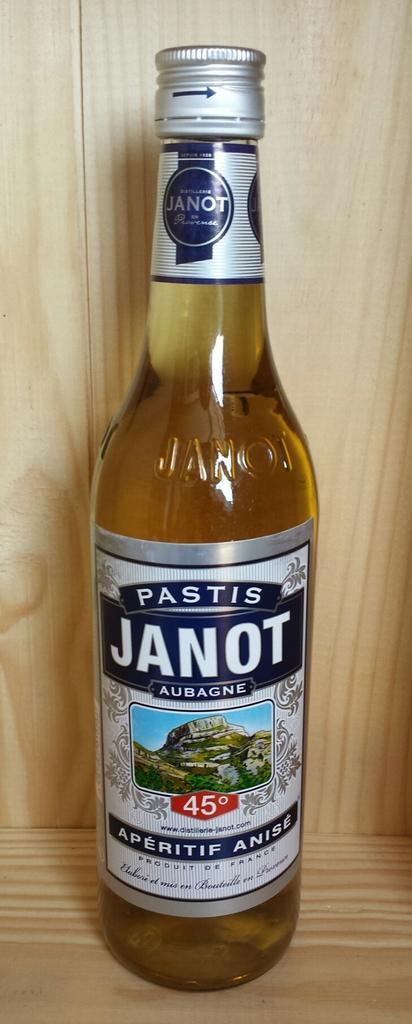Provide a one-sentence caption for the provided image. An unopened bottle of Pastis Janot on a wooden shelf. 